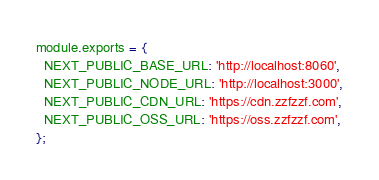<code> <loc_0><loc_0><loc_500><loc_500><_JavaScript_>module.exports = {
  NEXT_PUBLIC_BASE_URL: 'http://localhost:8060',
  NEXT_PUBLIC_NODE_URL: 'http://localhost:3000',
  NEXT_PUBLIC_CDN_URL: 'https://cdn.zzfzzf.com',
  NEXT_PUBLIC_OSS_URL: 'https://oss.zzfzzf.com',
};
</code> 